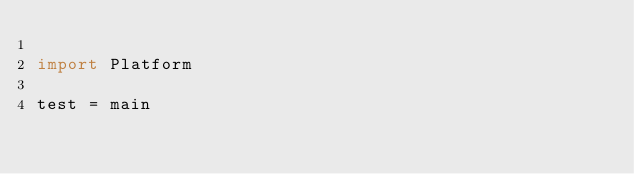<code> <loc_0><loc_0><loc_500><loc_500><_Haskell_>
import Platform

test = main
</code> 